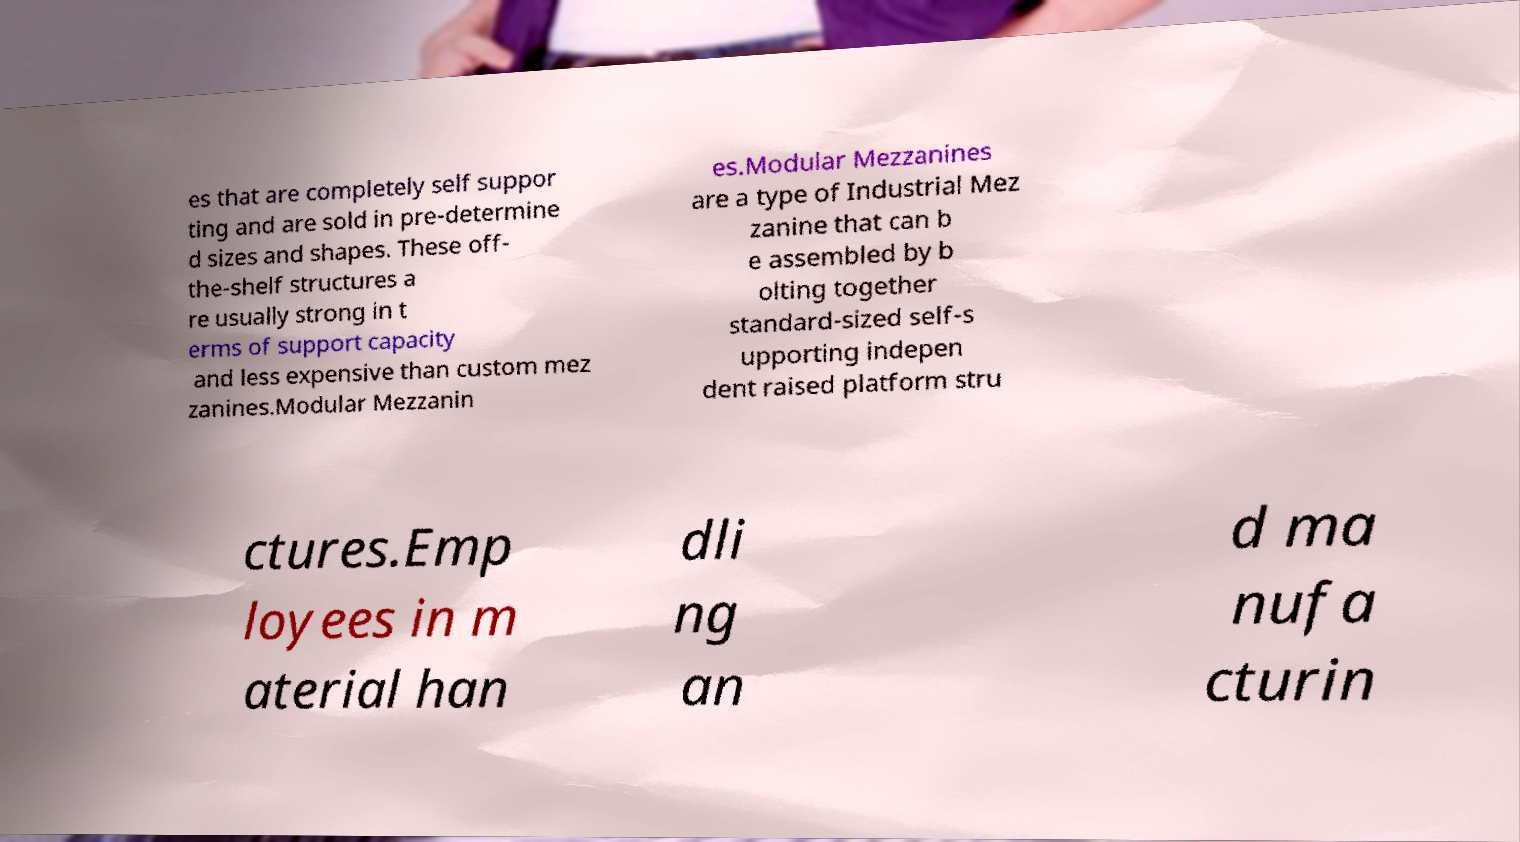Can you read and provide the text displayed in the image?This photo seems to have some interesting text. Can you extract and type it out for me? es that are completely self suppor ting and are sold in pre-determine d sizes and shapes. These off- the-shelf structures a re usually strong in t erms of support capacity and less expensive than custom mez zanines.Modular Mezzanin es.Modular Mezzanines are a type of Industrial Mez zanine that can b e assembled by b olting together standard-sized self-s upporting indepen dent raised platform stru ctures.Emp loyees in m aterial han dli ng an d ma nufa cturin 